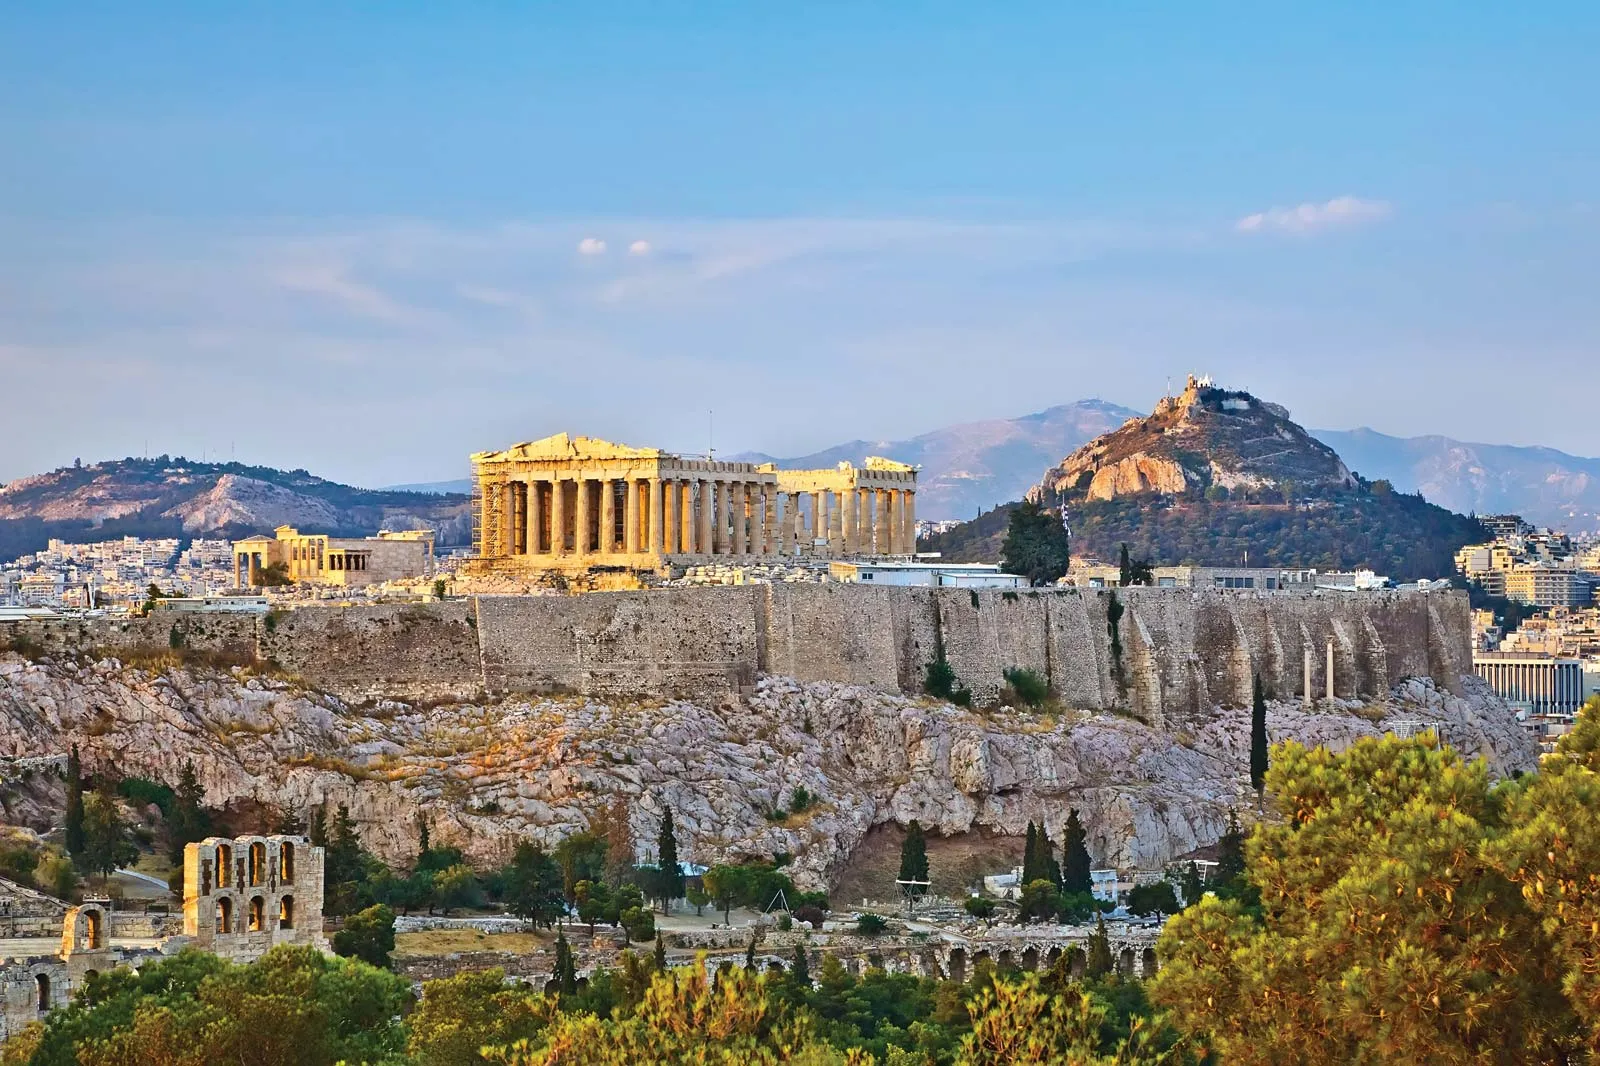Describe the architectural style of the structures seen in the image. The architectural style of the structures on the Acropolis, particularly the Parthenon, is a classic example of ancient Greek architecture. Known as the Doric order, it features sturdy columns with simple, rounded capitals and no base. The Parthenon’s proportionate harmony and precision in design epitomize the Greek pursuit of beauty through symmetry and balance. The use of white marble gives the structures a striking appearance against the clear blue skies. The attention to detail, both in the columns and the intricate friezes adorning the Parthenon, showcases the high level of craftsmanship of the period. This style has profoundly influenced Western architecture and continues to be celebrated for its timeless elegance. How do modern architects get inspired by these ancient structures? Modern architects draw inspiration from ancient Greek structures by incorporating principles of symmetry, proportion, and harmony into contemporary designs. The timeless nature of the Doric, Ionic, and Corinthian orders often finds echoes in modern public buildings, courthouses, and museums, reflecting the enduring appeal of Greek architecture. Additionally, the use of columns, pediments, and the emphasis on creating open, airy spaces with natural light are reminiscent of Greek architectural aesthetics. The reverence for historical craftsmanship and the integration of these classical elements with modern materials and technologies allow architects to create designs that are both functional and visually captivating, bridging the past with the present. 